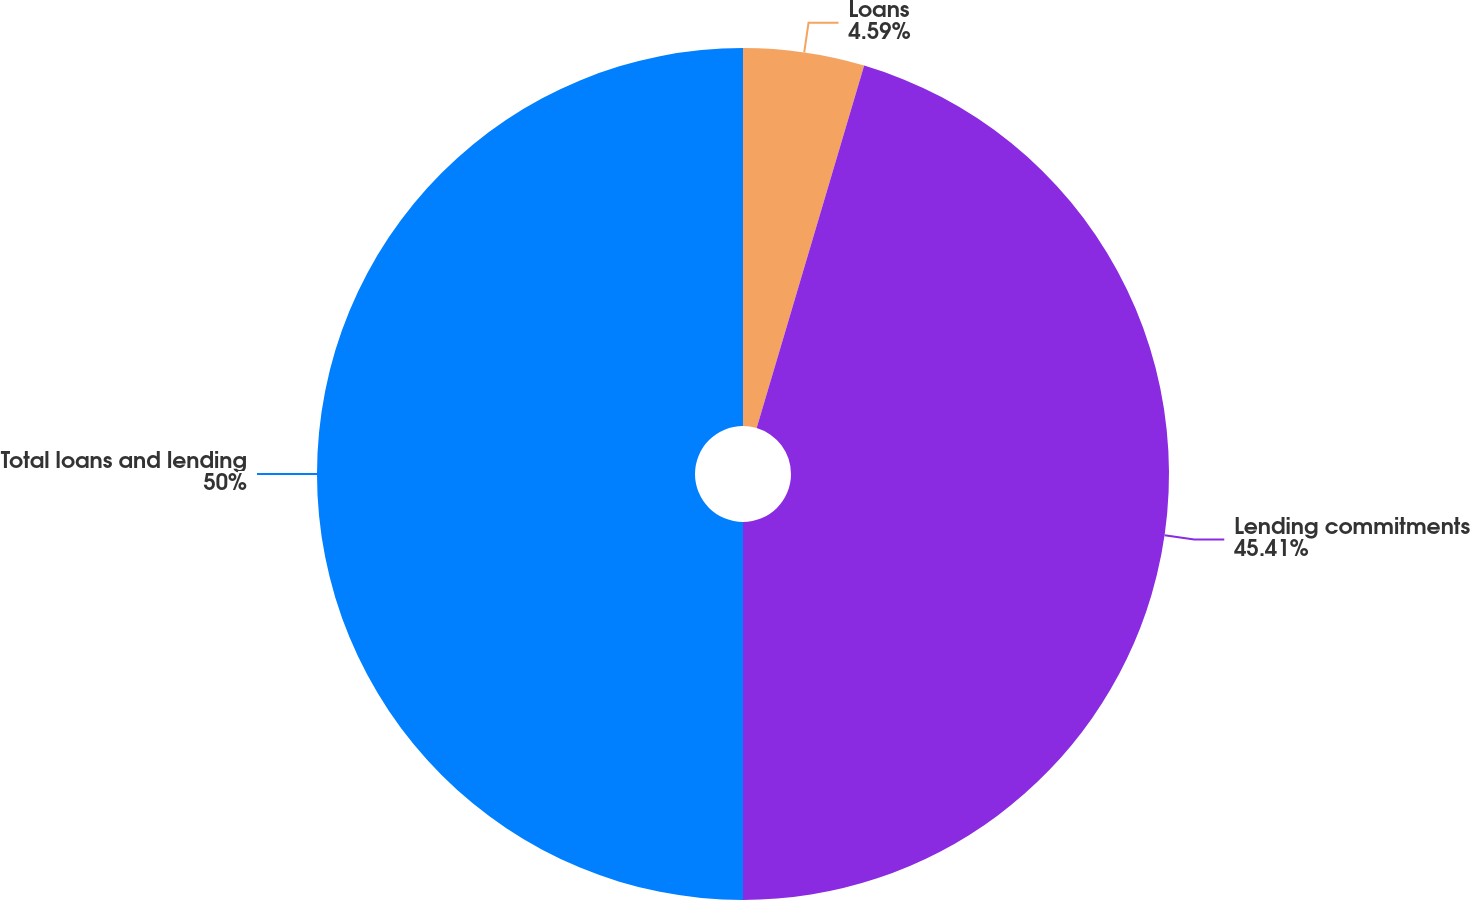Convert chart. <chart><loc_0><loc_0><loc_500><loc_500><pie_chart><fcel>Loans<fcel>Lending commitments<fcel>Total loans and lending<nl><fcel>4.59%<fcel>45.41%<fcel>50.0%<nl></chart> 